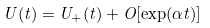Convert formula to latex. <formula><loc_0><loc_0><loc_500><loc_500>U ( t ) = U _ { + } ( t ) + O [ \exp ( \alpha t ) ]</formula> 